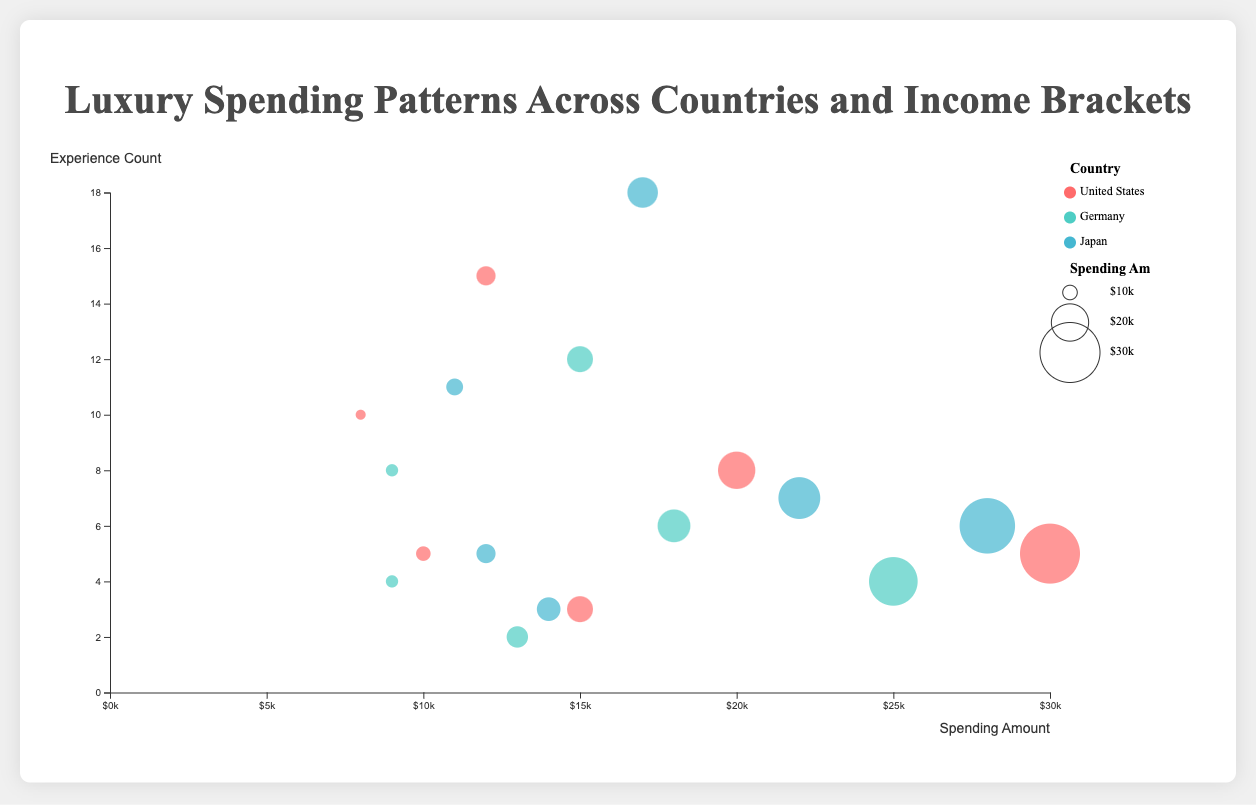What is the title of the chart? The title is usually at the top center of the chart and represents the topic or focus of the visual. Here, based on the `h1` HTML tag content, the title is "Luxury Spending Patterns Across Countries and Income Brackets".
Answer: Luxury Spending Patterns Across Countries and Income Brackets What are the axes labels in the chart? The x-axis typically represents one variable and the y-axis another. Here, the x-axis is labeled “Spending Amount” and the y-axis is labeled “Experience Count” as specified in the script.
Answer: Spending Amount, Experience Count Which country has the largest number of fine dining experiences for high-income brackets? To find this, look for the bubble with the highest experience count among high-income brackets for fine dining across countries. Japan has 18 experiences in fine dining for high-income brackets.
Answer: Japan Compare the spending on luxury travel between high-income brackets of the United States and Germany. Which is higher? Identify the bubbles representing high-income brackets and luxury travel for the United States and Germany. The United States spends $30,000, and Germany spends $25,000. The United States has higher spending.
Answer: United States What is the total spending on exclusive events across all countries for mid-high income brackets? Sum the spending amounts for exclusive events for all mid-high income brackets: United States ($10,000) + Germany ($9,000) + Japan ($12,000). Therefore, the total spending is $31,000.
Answer: $31,000 Which country has the least spending amount on luxury travel among mid-high income brackets? Compare the bubbles representing mid-high income brackets and luxury travel for each country. Germany has the least spending amount of $13,000.
Answer: Germany Which country appears to have more balanced spending across all luxury categories for high-income brackets? Observe the distribution of bubble sizes (representing spending) and counts for high-income brackets across luxury categories. Japan seems more balanced with relatively similar bubble sizes for luxury travel, fine dining, and exclusive events.
Answer: Japan How many fine dining experiences are there in Japan for mid-high income brackets? Look at the bubble for mid-high income brackets and fine dining experiences in Japan. It shows that there are 11 fine dining experiences.
Answer: 11 Between high-income and mid-high income brackets in Japan, which has a higher total spending on exclusive events? Compare the spending amounts on exclusive events for high-income ($22,000) and mid-high income ($12,000) brackets in Japan. The high-income bracket has higher total spending.
Answer: High-income Which expense category has the highest average spending amount for high-income brackets across all countries? Calculate the average spending for high-income brackets in each category: 
Luxury travel: (30000 (US) + 25000 (Germany) + 28000 (Japan)) / 3 = 27667. 
Fine dining: (12000 (US) + 15000 (Germany) + 17000 (Japan)) / 3 = 14667. 
Exclusive events: (20000 (US) + 18000 (Germany) + 22000 (Japan)) / 3 = 20000. Luxury travel has the highest average spending.
Answer: Luxury Travel 